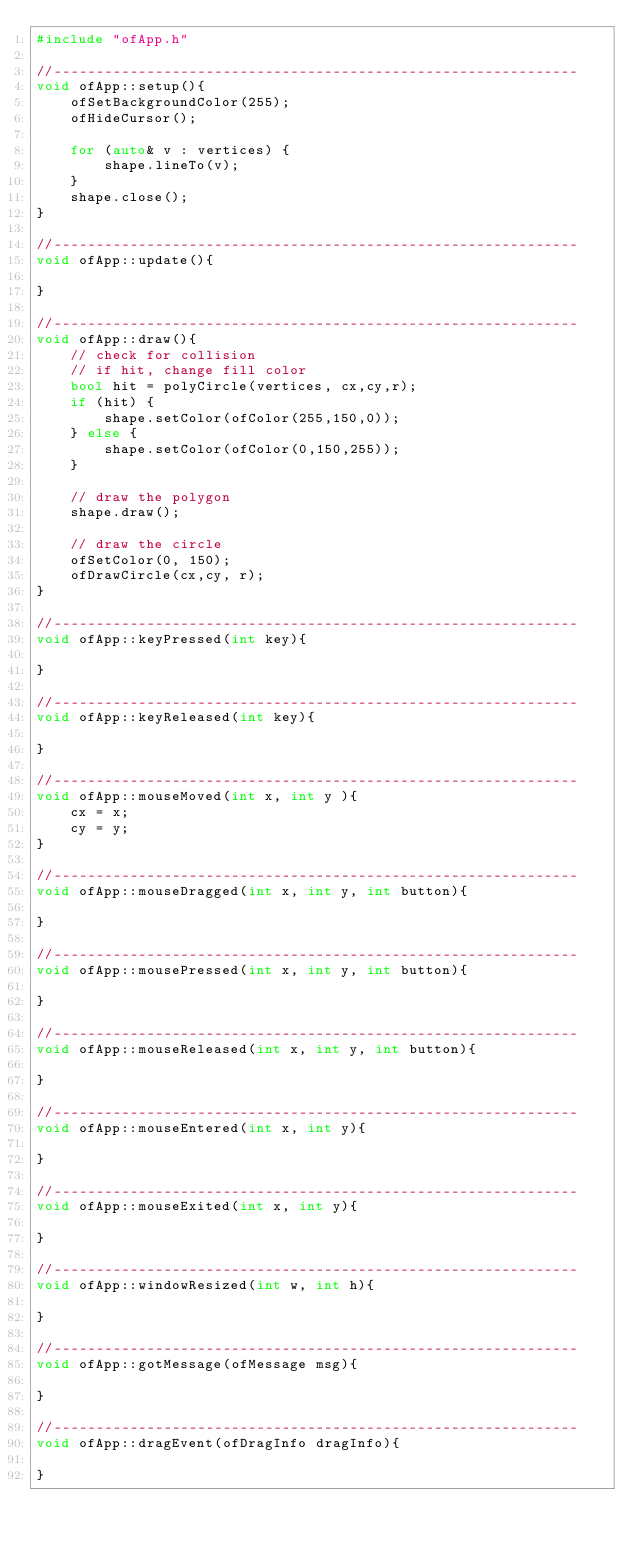<code> <loc_0><loc_0><loc_500><loc_500><_C++_>#include "ofApp.h"

//--------------------------------------------------------------
void ofApp::setup(){
    ofSetBackgroundColor(255);
    ofHideCursor();

    for (auto& v : vertices) {
        shape.lineTo(v);
    }
    shape.close();
}

//--------------------------------------------------------------
void ofApp::update(){
    
}

//--------------------------------------------------------------
void ofApp::draw(){
    // check for collision
    // if hit, change fill color
    bool hit = polyCircle(vertices, cx,cy,r);
    if (hit) {
        shape.setColor(ofColor(255,150,0));
    } else {
        shape.setColor(ofColor(0,150,255));
    }

    // draw the polygon
    shape.draw();

    // draw the circle
    ofSetColor(0, 150);
    ofDrawCircle(cx,cy, r);
}

//--------------------------------------------------------------
void ofApp::keyPressed(int key){

}

//--------------------------------------------------------------
void ofApp::keyReleased(int key){

}

//--------------------------------------------------------------
void ofApp::mouseMoved(int x, int y ){
    cx = x;
    cy = y;
}

//--------------------------------------------------------------
void ofApp::mouseDragged(int x, int y, int button){

}

//--------------------------------------------------------------
void ofApp::mousePressed(int x, int y, int button){

}

//--------------------------------------------------------------
void ofApp::mouseReleased(int x, int y, int button){

}

//--------------------------------------------------------------
void ofApp::mouseEntered(int x, int y){

}

//--------------------------------------------------------------
void ofApp::mouseExited(int x, int y){

}

//--------------------------------------------------------------
void ofApp::windowResized(int w, int h){

}

//--------------------------------------------------------------
void ofApp::gotMessage(ofMessage msg){

}

//--------------------------------------------------------------
void ofApp::dragEvent(ofDragInfo dragInfo){ 

}
</code> 